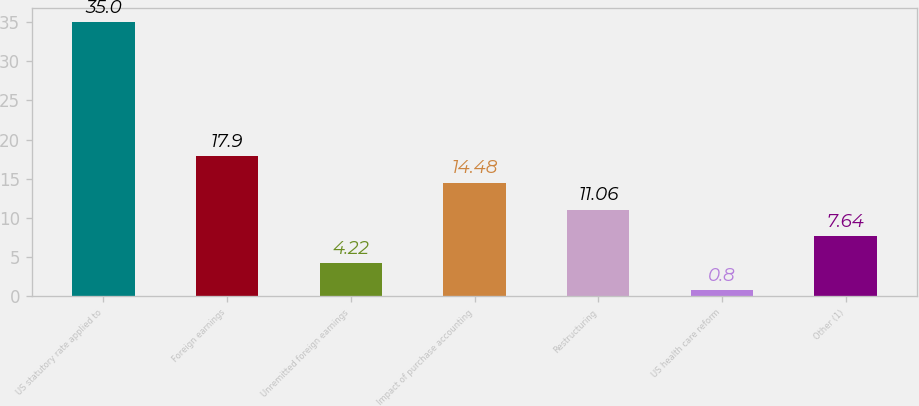Convert chart to OTSL. <chart><loc_0><loc_0><loc_500><loc_500><bar_chart><fcel>US statutory rate applied to<fcel>Foreign earnings<fcel>Unremitted foreign earnings<fcel>Impact of purchase accounting<fcel>Restructuring<fcel>US health care reform<fcel>Other (1)<nl><fcel>35<fcel>17.9<fcel>4.22<fcel>14.48<fcel>11.06<fcel>0.8<fcel>7.64<nl></chart> 